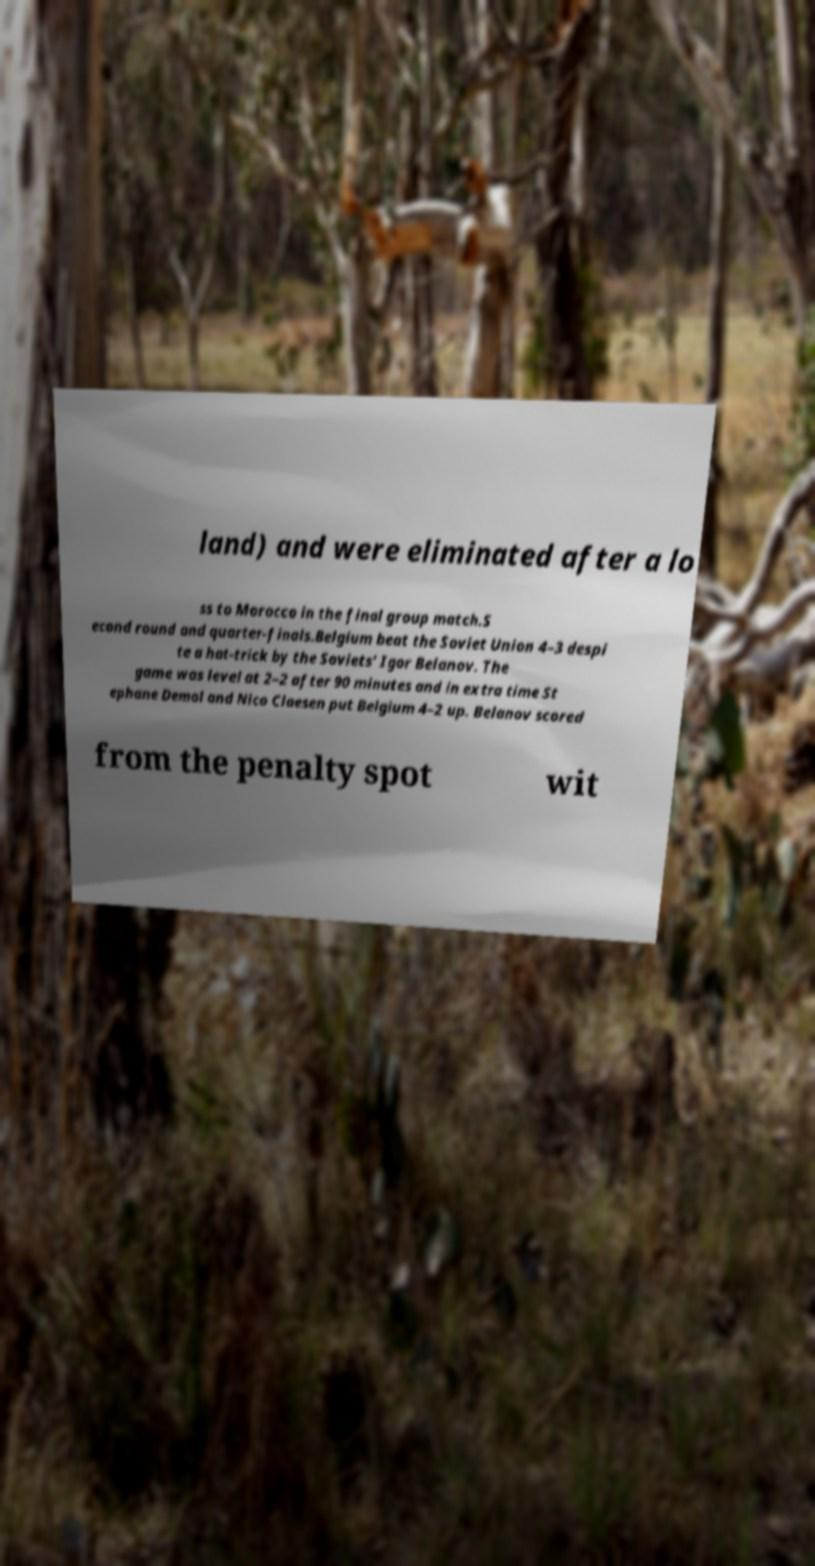What messages or text are displayed in this image? I need them in a readable, typed format. land) and were eliminated after a lo ss to Morocco in the final group match.S econd round and quarter-finals.Belgium beat the Soviet Union 4–3 despi te a hat-trick by the Soviets' Igor Belanov. The game was level at 2–2 after 90 minutes and in extra time St ephane Demol and Nico Claesen put Belgium 4–2 up. Belanov scored from the penalty spot wit 